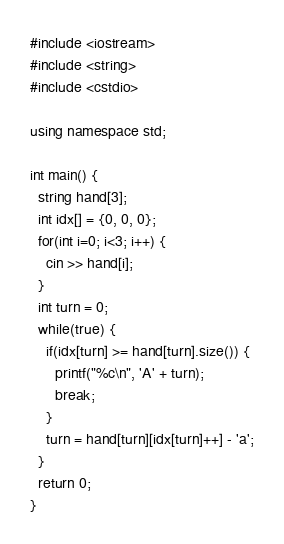Convert code to text. <code><loc_0><loc_0><loc_500><loc_500><_C++_>#include <iostream>
#include <string>
#include <cstdio>

using namespace std;

int main() {
  string hand[3];
  int idx[] = {0, 0, 0};
  for(int i=0; i<3; i++) {
    cin >> hand[i];
  }
  int turn = 0;
  while(true) {
    if(idx[turn] >= hand[turn].size()) {
      printf("%c\n", 'A' + turn);
      break;
    }
    turn = hand[turn][idx[turn]++] - 'a';
  }
  return 0;
}</code> 